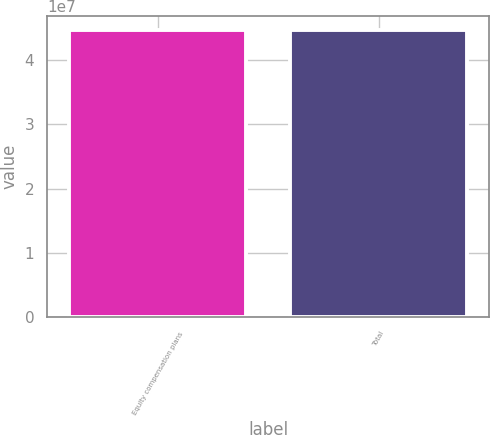Convert chart to OTSL. <chart><loc_0><loc_0><loc_500><loc_500><bar_chart><fcel>Equity compensation plans<fcel>Total<nl><fcel>4.45898e+07<fcel>4.45898e+07<nl></chart> 